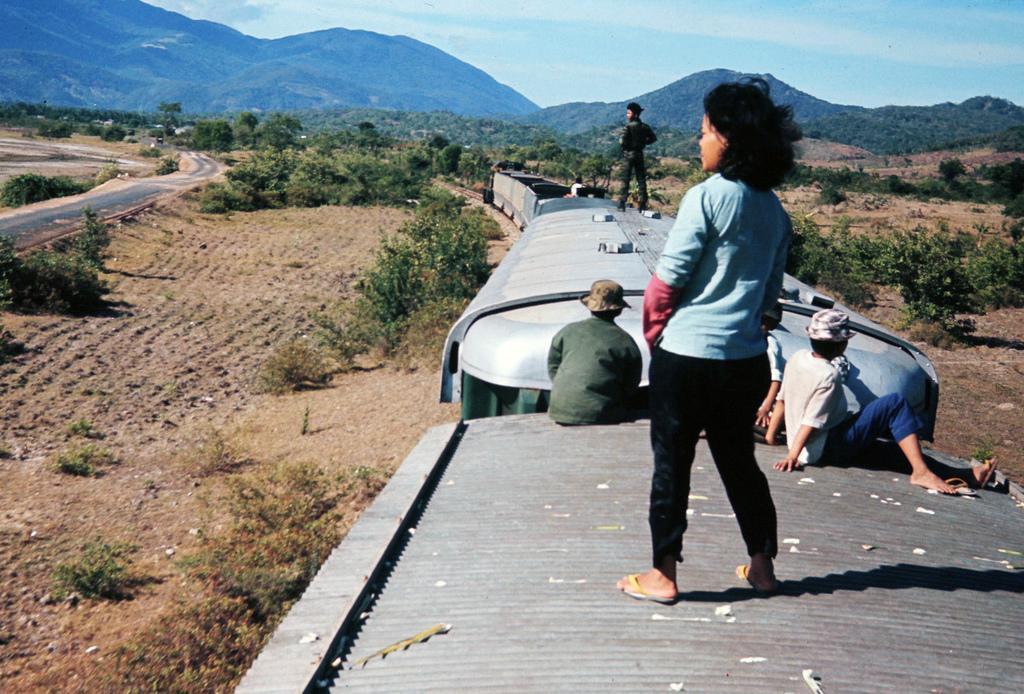Please provide a concise description of this image. In the picture we can see a train and on top of it, we can see some people are sitting and two people are standing and besides the train we can see a muddy surface and on it we can see many plants and besides, we can also see a road and in the background we can see trees and hills and behind it we can see a sky with clouds. 